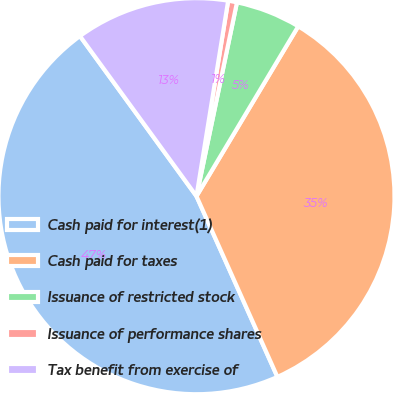<chart> <loc_0><loc_0><loc_500><loc_500><pie_chart><fcel>Cash paid for interest(1)<fcel>Cash paid for taxes<fcel>Issuance of restricted stock<fcel>Issuance of performance shares<fcel>Tax benefit from exercise of<nl><fcel>46.69%<fcel>34.71%<fcel>5.31%<fcel>0.72%<fcel>12.57%<nl></chart> 